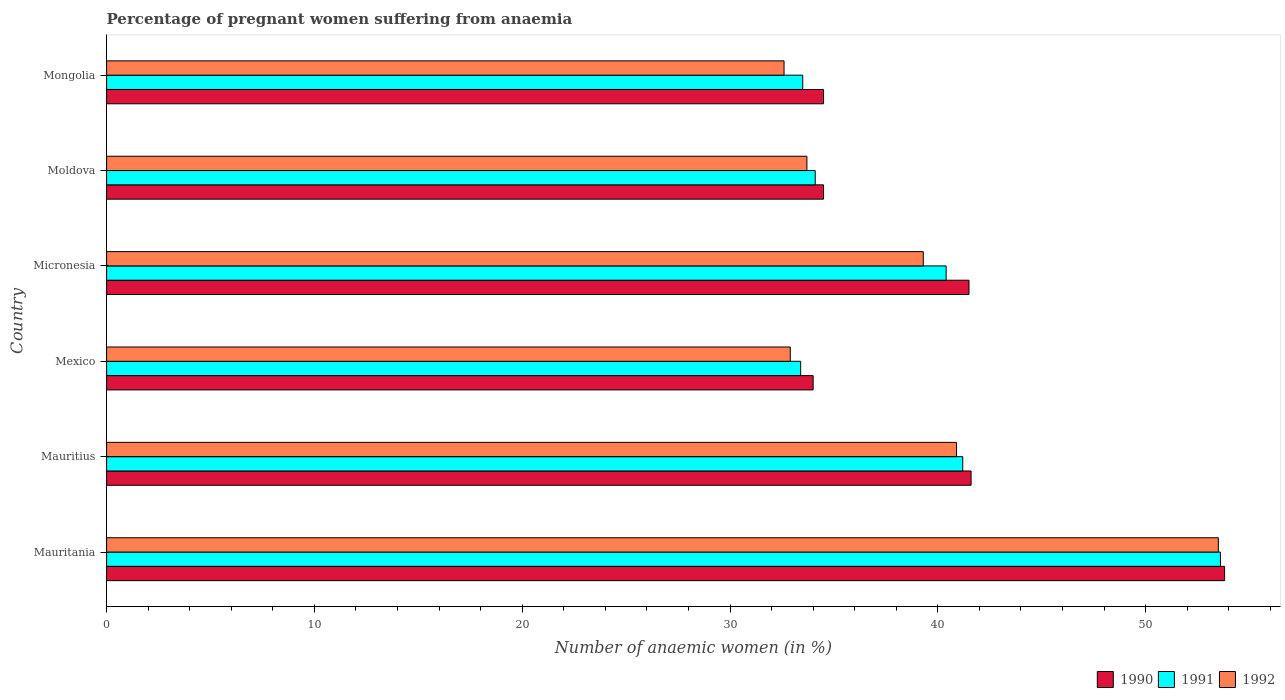Are the number of bars on each tick of the Y-axis equal?
Your answer should be compact. Yes. In how many cases, is the number of bars for a given country not equal to the number of legend labels?
Ensure brevity in your answer.  0. What is the number of anaemic women in 1990 in Micronesia?
Offer a terse response. 41.5. Across all countries, what is the maximum number of anaemic women in 1991?
Your response must be concise. 53.6. In which country was the number of anaemic women in 1990 maximum?
Ensure brevity in your answer.  Mauritania. In which country was the number of anaemic women in 1992 minimum?
Your response must be concise. Mongolia. What is the total number of anaemic women in 1992 in the graph?
Your answer should be compact. 232.9. What is the difference between the number of anaemic women in 1992 in Mauritania and that in Mauritius?
Keep it short and to the point. 12.6. What is the difference between the number of anaemic women in 1991 in Mauritius and the number of anaemic women in 1990 in Mongolia?
Your answer should be compact. 6.7. What is the average number of anaemic women in 1991 per country?
Your response must be concise. 39.37. What is the difference between the number of anaemic women in 1992 and number of anaemic women in 1990 in Mexico?
Keep it short and to the point. -1.1. What is the ratio of the number of anaemic women in 1990 in Mauritius to that in Mexico?
Provide a short and direct response. 1.22. Is the number of anaemic women in 1991 in Mauritania less than that in Moldova?
Offer a very short reply. No. Is the difference between the number of anaemic women in 1992 in Mexico and Moldova greater than the difference between the number of anaemic women in 1990 in Mexico and Moldova?
Offer a very short reply. No. What is the difference between the highest and the second highest number of anaemic women in 1991?
Provide a succinct answer. 12.4. What is the difference between the highest and the lowest number of anaemic women in 1992?
Provide a short and direct response. 20.9. Is the sum of the number of anaemic women in 1992 in Micronesia and Moldova greater than the maximum number of anaemic women in 1990 across all countries?
Your answer should be very brief. Yes. What does the 2nd bar from the top in Mexico represents?
Provide a short and direct response. 1991. What does the 3rd bar from the bottom in Mauritania represents?
Ensure brevity in your answer.  1992. Is it the case that in every country, the sum of the number of anaemic women in 1991 and number of anaemic women in 1990 is greater than the number of anaemic women in 1992?
Provide a short and direct response. Yes. How many bars are there?
Provide a succinct answer. 18. How many countries are there in the graph?
Your answer should be compact. 6. What is the difference between two consecutive major ticks on the X-axis?
Offer a terse response. 10. Does the graph contain any zero values?
Offer a very short reply. No. Does the graph contain grids?
Offer a very short reply. No. How many legend labels are there?
Provide a short and direct response. 3. What is the title of the graph?
Provide a short and direct response. Percentage of pregnant women suffering from anaemia. Does "1992" appear as one of the legend labels in the graph?
Your answer should be very brief. Yes. What is the label or title of the X-axis?
Your response must be concise. Number of anaemic women (in %). What is the label or title of the Y-axis?
Offer a very short reply. Country. What is the Number of anaemic women (in %) of 1990 in Mauritania?
Offer a terse response. 53.8. What is the Number of anaemic women (in %) of 1991 in Mauritania?
Provide a short and direct response. 53.6. What is the Number of anaemic women (in %) of 1992 in Mauritania?
Provide a succinct answer. 53.5. What is the Number of anaemic women (in %) of 1990 in Mauritius?
Ensure brevity in your answer.  41.6. What is the Number of anaemic women (in %) of 1991 in Mauritius?
Your answer should be very brief. 41.2. What is the Number of anaemic women (in %) of 1992 in Mauritius?
Offer a terse response. 40.9. What is the Number of anaemic women (in %) of 1991 in Mexico?
Your response must be concise. 33.4. What is the Number of anaemic women (in %) of 1992 in Mexico?
Your response must be concise. 32.9. What is the Number of anaemic women (in %) of 1990 in Micronesia?
Make the answer very short. 41.5. What is the Number of anaemic women (in %) of 1991 in Micronesia?
Ensure brevity in your answer.  40.4. What is the Number of anaemic women (in %) in 1992 in Micronesia?
Make the answer very short. 39.3. What is the Number of anaemic women (in %) of 1990 in Moldova?
Ensure brevity in your answer.  34.5. What is the Number of anaemic women (in %) in 1991 in Moldova?
Keep it short and to the point. 34.1. What is the Number of anaemic women (in %) of 1992 in Moldova?
Give a very brief answer. 33.7. What is the Number of anaemic women (in %) in 1990 in Mongolia?
Give a very brief answer. 34.5. What is the Number of anaemic women (in %) of 1991 in Mongolia?
Your answer should be very brief. 33.5. What is the Number of anaemic women (in %) of 1992 in Mongolia?
Provide a short and direct response. 32.6. Across all countries, what is the maximum Number of anaemic women (in %) of 1990?
Provide a succinct answer. 53.8. Across all countries, what is the maximum Number of anaemic women (in %) of 1991?
Your response must be concise. 53.6. Across all countries, what is the maximum Number of anaemic women (in %) in 1992?
Offer a very short reply. 53.5. Across all countries, what is the minimum Number of anaemic women (in %) of 1991?
Provide a succinct answer. 33.4. Across all countries, what is the minimum Number of anaemic women (in %) of 1992?
Ensure brevity in your answer.  32.6. What is the total Number of anaemic women (in %) of 1990 in the graph?
Offer a very short reply. 239.9. What is the total Number of anaemic women (in %) in 1991 in the graph?
Offer a very short reply. 236.2. What is the total Number of anaemic women (in %) of 1992 in the graph?
Your answer should be very brief. 232.9. What is the difference between the Number of anaemic women (in %) in 1990 in Mauritania and that in Mauritius?
Offer a very short reply. 12.2. What is the difference between the Number of anaemic women (in %) of 1992 in Mauritania and that in Mauritius?
Give a very brief answer. 12.6. What is the difference between the Number of anaemic women (in %) of 1990 in Mauritania and that in Mexico?
Offer a very short reply. 19.8. What is the difference between the Number of anaemic women (in %) of 1991 in Mauritania and that in Mexico?
Make the answer very short. 20.2. What is the difference between the Number of anaemic women (in %) in 1992 in Mauritania and that in Mexico?
Your response must be concise. 20.6. What is the difference between the Number of anaemic women (in %) in 1990 in Mauritania and that in Micronesia?
Give a very brief answer. 12.3. What is the difference between the Number of anaemic women (in %) in 1991 in Mauritania and that in Micronesia?
Offer a very short reply. 13.2. What is the difference between the Number of anaemic women (in %) of 1990 in Mauritania and that in Moldova?
Offer a very short reply. 19.3. What is the difference between the Number of anaemic women (in %) in 1992 in Mauritania and that in Moldova?
Ensure brevity in your answer.  19.8. What is the difference between the Number of anaemic women (in %) of 1990 in Mauritania and that in Mongolia?
Give a very brief answer. 19.3. What is the difference between the Number of anaemic women (in %) of 1991 in Mauritania and that in Mongolia?
Ensure brevity in your answer.  20.1. What is the difference between the Number of anaemic women (in %) in 1992 in Mauritania and that in Mongolia?
Your response must be concise. 20.9. What is the difference between the Number of anaemic women (in %) of 1991 in Mauritius and that in Mexico?
Your answer should be compact. 7.8. What is the difference between the Number of anaemic women (in %) of 1991 in Mauritius and that in Moldova?
Your response must be concise. 7.1. What is the difference between the Number of anaemic women (in %) of 1992 in Mauritius and that in Mongolia?
Offer a terse response. 8.3. What is the difference between the Number of anaemic women (in %) in 1990 in Mexico and that in Micronesia?
Your response must be concise. -7.5. What is the difference between the Number of anaemic women (in %) of 1991 in Mexico and that in Micronesia?
Your answer should be very brief. -7. What is the difference between the Number of anaemic women (in %) in 1992 in Mexico and that in Micronesia?
Offer a terse response. -6.4. What is the difference between the Number of anaemic women (in %) in 1990 in Mexico and that in Moldova?
Your response must be concise. -0.5. What is the difference between the Number of anaemic women (in %) of 1990 in Mexico and that in Mongolia?
Give a very brief answer. -0.5. What is the difference between the Number of anaemic women (in %) of 1992 in Mexico and that in Mongolia?
Make the answer very short. 0.3. What is the difference between the Number of anaemic women (in %) in 1990 in Micronesia and that in Moldova?
Offer a terse response. 7. What is the difference between the Number of anaemic women (in %) in 1992 in Micronesia and that in Moldova?
Give a very brief answer. 5.6. What is the difference between the Number of anaemic women (in %) in 1991 in Micronesia and that in Mongolia?
Your response must be concise. 6.9. What is the difference between the Number of anaemic women (in %) in 1992 in Micronesia and that in Mongolia?
Ensure brevity in your answer.  6.7. What is the difference between the Number of anaemic women (in %) in 1992 in Moldova and that in Mongolia?
Offer a terse response. 1.1. What is the difference between the Number of anaemic women (in %) of 1990 in Mauritania and the Number of anaemic women (in %) of 1991 in Mexico?
Make the answer very short. 20.4. What is the difference between the Number of anaemic women (in %) in 1990 in Mauritania and the Number of anaemic women (in %) in 1992 in Mexico?
Offer a very short reply. 20.9. What is the difference between the Number of anaemic women (in %) in 1991 in Mauritania and the Number of anaemic women (in %) in 1992 in Mexico?
Keep it short and to the point. 20.7. What is the difference between the Number of anaemic women (in %) of 1990 in Mauritania and the Number of anaemic women (in %) of 1991 in Micronesia?
Provide a short and direct response. 13.4. What is the difference between the Number of anaemic women (in %) in 1990 in Mauritania and the Number of anaemic women (in %) in 1991 in Moldova?
Your answer should be compact. 19.7. What is the difference between the Number of anaemic women (in %) in 1990 in Mauritania and the Number of anaemic women (in %) in 1992 in Moldova?
Give a very brief answer. 20.1. What is the difference between the Number of anaemic women (in %) of 1991 in Mauritania and the Number of anaemic women (in %) of 1992 in Moldova?
Offer a terse response. 19.9. What is the difference between the Number of anaemic women (in %) of 1990 in Mauritania and the Number of anaemic women (in %) of 1991 in Mongolia?
Provide a succinct answer. 20.3. What is the difference between the Number of anaemic women (in %) in 1990 in Mauritania and the Number of anaemic women (in %) in 1992 in Mongolia?
Offer a terse response. 21.2. What is the difference between the Number of anaemic women (in %) of 1990 in Mauritius and the Number of anaemic women (in %) of 1992 in Mexico?
Ensure brevity in your answer.  8.7. What is the difference between the Number of anaemic women (in %) in 1991 in Mauritius and the Number of anaemic women (in %) in 1992 in Mexico?
Provide a short and direct response. 8.3. What is the difference between the Number of anaemic women (in %) of 1990 in Mauritius and the Number of anaemic women (in %) of 1991 in Micronesia?
Provide a succinct answer. 1.2. What is the difference between the Number of anaemic women (in %) of 1990 in Mauritius and the Number of anaemic women (in %) of 1992 in Micronesia?
Ensure brevity in your answer.  2.3. What is the difference between the Number of anaemic women (in %) of 1991 in Mauritius and the Number of anaemic women (in %) of 1992 in Micronesia?
Offer a terse response. 1.9. What is the difference between the Number of anaemic women (in %) in 1990 in Mauritius and the Number of anaemic women (in %) in 1991 in Moldova?
Offer a very short reply. 7.5. What is the difference between the Number of anaemic women (in %) in 1991 in Mauritius and the Number of anaemic women (in %) in 1992 in Moldova?
Keep it short and to the point. 7.5. What is the difference between the Number of anaemic women (in %) of 1990 in Mexico and the Number of anaemic women (in %) of 1991 in Micronesia?
Provide a short and direct response. -6.4. What is the difference between the Number of anaemic women (in %) of 1991 in Mexico and the Number of anaemic women (in %) of 1992 in Micronesia?
Provide a short and direct response. -5.9. What is the difference between the Number of anaemic women (in %) of 1990 in Mexico and the Number of anaemic women (in %) of 1991 in Moldova?
Your response must be concise. -0.1. What is the difference between the Number of anaemic women (in %) of 1990 in Mexico and the Number of anaemic women (in %) of 1992 in Moldova?
Ensure brevity in your answer.  0.3. What is the difference between the Number of anaemic women (in %) of 1991 in Mexico and the Number of anaemic women (in %) of 1992 in Moldova?
Offer a terse response. -0.3. What is the difference between the Number of anaemic women (in %) in 1990 in Mexico and the Number of anaemic women (in %) in 1991 in Mongolia?
Ensure brevity in your answer.  0.5. What is the difference between the Number of anaemic women (in %) in 1990 in Mexico and the Number of anaemic women (in %) in 1992 in Mongolia?
Your answer should be compact. 1.4. What is the difference between the Number of anaemic women (in %) in 1991 in Micronesia and the Number of anaemic women (in %) in 1992 in Moldova?
Offer a terse response. 6.7. What is the difference between the Number of anaemic women (in %) in 1990 in Micronesia and the Number of anaemic women (in %) in 1992 in Mongolia?
Provide a succinct answer. 8.9. What is the difference between the Number of anaemic women (in %) in 1990 in Moldova and the Number of anaemic women (in %) in 1991 in Mongolia?
Keep it short and to the point. 1. What is the difference between the Number of anaemic women (in %) in 1990 in Moldova and the Number of anaemic women (in %) in 1992 in Mongolia?
Provide a succinct answer. 1.9. What is the difference between the Number of anaemic women (in %) in 1991 in Moldova and the Number of anaemic women (in %) in 1992 in Mongolia?
Offer a terse response. 1.5. What is the average Number of anaemic women (in %) of 1990 per country?
Provide a short and direct response. 39.98. What is the average Number of anaemic women (in %) of 1991 per country?
Keep it short and to the point. 39.37. What is the average Number of anaemic women (in %) in 1992 per country?
Ensure brevity in your answer.  38.82. What is the difference between the Number of anaemic women (in %) in 1990 and Number of anaemic women (in %) in 1991 in Mauritania?
Offer a terse response. 0.2. What is the difference between the Number of anaemic women (in %) in 1991 and Number of anaemic women (in %) in 1992 in Mauritania?
Your response must be concise. 0.1. What is the difference between the Number of anaemic women (in %) of 1990 and Number of anaemic women (in %) of 1991 in Mauritius?
Make the answer very short. 0.4. What is the difference between the Number of anaemic women (in %) of 1991 and Number of anaemic women (in %) of 1992 in Mauritius?
Provide a short and direct response. 0.3. What is the difference between the Number of anaemic women (in %) in 1990 and Number of anaemic women (in %) in 1991 in Mexico?
Your response must be concise. 0.6. What is the difference between the Number of anaemic women (in %) in 1991 and Number of anaemic women (in %) in 1992 in Mexico?
Ensure brevity in your answer.  0.5. What is the difference between the Number of anaemic women (in %) of 1990 and Number of anaemic women (in %) of 1991 in Micronesia?
Offer a terse response. 1.1. What is the difference between the Number of anaemic women (in %) in 1991 and Number of anaemic women (in %) in 1992 in Micronesia?
Your answer should be compact. 1.1. What is the difference between the Number of anaemic women (in %) in 1990 and Number of anaemic women (in %) in 1992 in Moldova?
Keep it short and to the point. 0.8. What is the difference between the Number of anaemic women (in %) of 1991 and Number of anaemic women (in %) of 1992 in Moldova?
Keep it short and to the point. 0.4. What is the difference between the Number of anaemic women (in %) in 1990 and Number of anaemic women (in %) in 1992 in Mongolia?
Your answer should be very brief. 1.9. What is the ratio of the Number of anaemic women (in %) in 1990 in Mauritania to that in Mauritius?
Keep it short and to the point. 1.29. What is the ratio of the Number of anaemic women (in %) in 1991 in Mauritania to that in Mauritius?
Offer a terse response. 1.3. What is the ratio of the Number of anaemic women (in %) of 1992 in Mauritania to that in Mauritius?
Your answer should be compact. 1.31. What is the ratio of the Number of anaemic women (in %) in 1990 in Mauritania to that in Mexico?
Provide a succinct answer. 1.58. What is the ratio of the Number of anaemic women (in %) of 1991 in Mauritania to that in Mexico?
Provide a short and direct response. 1.6. What is the ratio of the Number of anaemic women (in %) in 1992 in Mauritania to that in Mexico?
Offer a very short reply. 1.63. What is the ratio of the Number of anaemic women (in %) in 1990 in Mauritania to that in Micronesia?
Your answer should be compact. 1.3. What is the ratio of the Number of anaemic women (in %) of 1991 in Mauritania to that in Micronesia?
Your response must be concise. 1.33. What is the ratio of the Number of anaemic women (in %) in 1992 in Mauritania to that in Micronesia?
Offer a terse response. 1.36. What is the ratio of the Number of anaemic women (in %) of 1990 in Mauritania to that in Moldova?
Provide a short and direct response. 1.56. What is the ratio of the Number of anaemic women (in %) in 1991 in Mauritania to that in Moldova?
Make the answer very short. 1.57. What is the ratio of the Number of anaemic women (in %) of 1992 in Mauritania to that in Moldova?
Provide a short and direct response. 1.59. What is the ratio of the Number of anaemic women (in %) in 1990 in Mauritania to that in Mongolia?
Keep it short and to the point. 1.56. What is the ratio of the Number of anaemic women (in %) of 1991 in Mauritania to that in Mongolia?
Give a very brief answer. 1.6. What is the ratio of the Number of anaemic women (in %) in 1992 in Mauritania to that in Mongolia?
Provide a succinct answer. 1.64. What is the ratio of the Number of anaemic women (in %) in 1990 in Mauritius to that in Mexico?
Offer a terse response. 1.22. What is the ratio of the Number of anaemic women (in %) of 1991 in Mauritius to that in Mexico?
Offer a terse response. 1.23. What is the ratio of the Number of anaemic women (in %) of 1992 in Mauritius to that in Mexico?
Your answer should be compact. 1.24. What is the ratio of the Number of anaemic women (in %) in 1991 in Mauritius to that in Micronesia?
Your answer should be very brief. 1.02. What is the ratio of the Number of anaemic women (in %) in 1992 in Mauritius to that in Micronesia?
Your answer should be compact. 1.04. What is the ratio of the Number of anaemic women (in %) in 1990 in Mauritius to that in Moldova?
Provide a short and direct response. 1.21. What is the ratio of the Number of anaemic women (in %) in 1991 in Mauritius to that in Moldova?
Provide a short and direct response. 1.21. What is the ratio of the Number of anaemic women (in %) in 1992 in Mauritius to that in Moldova?
Your answer should be compact. 1.21. What is the ratio of the Number of anaemic women (in %) of 1990 in Mauritius to that in Mongolia?
Ensure brevity in your answer.  1.21. What is the ratio of the Number of anaemic women (in %) of 1991 in Mauritius to that in Mongolia?
Provide a succinct answer. 1.23. What is the ratio of the Number of anaemic women (in %) in 1992 in Mauritius to that in Mongolia?
Provide a short and direct response. 1.25. What is the ratio of the Number of anaemic women (in %) in 1990 in Mexico to that in Micronesia?
Provide a short and direct response. 0.82. What is the ratio of the Number of anaemic women (in %) of 1991 in Mexico to that in Micronesia?
Your response must be concise. 0.83. What is the ratio of the Number of anaemic women (in %) in 1992 in Mexico to that in Micronesia?
Offer a very short reply. 0.84. What is the ratio of the Number of anaemic women (in %) of 1990 in Mexico to that in Moldova?
Ensure brevity in your answer.  0.99. What is the ratio of the Number of anaemic women (in %) in 1991 in Mexico to that in Moldova?
Provide a short and direct response. 0.98. What is the ratio of the Number of anaemic women (in %) of 1992 in Mexico to that in Moldova?
Provide a succinct answer. 0.98. What is the ratio of the Number of anaemic women (in %) of 1990 in Mexico to that in Mongolia?
Give a very brief answer. 0.99. What is the ratio of the Number of anaemic women (in %) of 1992 in Mexico to that in Mongolia?
Keep it short and to the point. 1.01. What is the ratio of the Number of anaemic women (in %) in 1990 in Micronesia to that in Moldova?
Offer a terse response. 1.2. What is the ratio of the Number of anaemic women (in %) of 1991 in Micronesia to that in Moldova?
Keep it short and to the point. 1.18. What is the ratio of the Number of anaemic women (in %) in 1992 in Micronesia to that in Moldova?
Your answer should be very brief. 1.17. What is the ratio of the Number of anaemic women (in %) in 1990 in Micronesia to that in Mongolia?
Offer a very short reply. 1.2. What is the ratio of the Number of anaemic women (in %) of 1991 in Micronesia to that in Mongolia?
Ensure brevity in your answer.  1.21. What is the ratio of the Number of anaemic women (in %) in 1992 in Micronesia to that in Mongolia?
Your answer should be very brief. 1.21. What is the ratio of the Number of anaemic women (in %) in 1990 in Moldova to that in Mongolia?
Provide a succinct answer. 1. What is the ratio of the Number of anaemic women (in %) in 1991 in Moldova to that in Mongolia?
Provide a succinct answer. 1.02. What is the ratio of the Number of anaemic women (in %) of 1992 in Moldova to that in Mongolia?
Offer a terse response. 1.03. What is the difference between the highest and the second highest Number of anaemic women (in %) of 1992?
Provide a short and direct response. 12.6. What is the difference between the highest and the lowest Number of anaemic women (in %) of 1990?
Offer a very short reply. 19.8. What is the difference between the highest and the lowest Number of anaemic women (in %) in 1991?
Give a very brief answer. 20.2. What is the difference between the highest and the lowest Number of anaemic women (in %) of 1992?
Give a very brief answer. 20.9. 